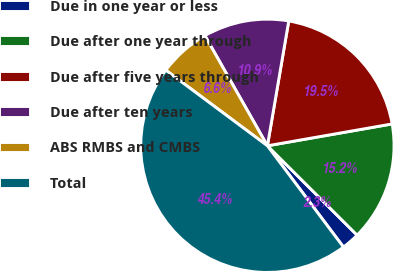<chart> <loc_0><loc_0><loc_500><loc_500><pie_chart><fcel>Due in one year or less<fcel>Due after one year through<fcel>Due after five years through<fcel>Due after ten years<fcel>ABS RMBS and CMBS<fcel>Total<nl><fcel>2.28%<fcel>15.23%<fcel>19.54%<fcel>10.91%<fcel>6.6%<fcel>45.43%<nl></chart> 